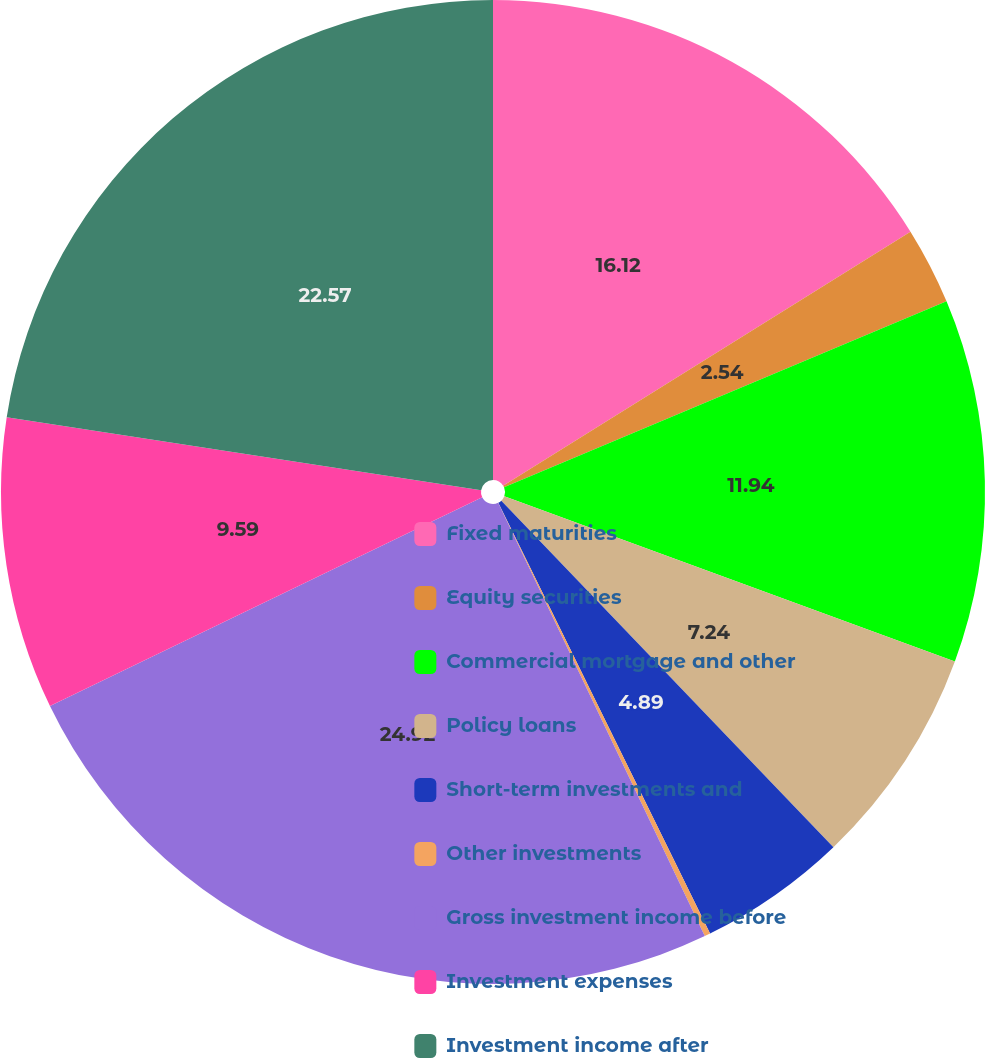<chart> <loc_0><loc_0><loc_500><loc_500><pie_chart><fcel>Fixed maturities<fcel>Equity securities<fcel>Commercial mortgage and other<fcel>Policy loans<fcel>Short-term investments and<fcel>Other investments<fcel>Gross investment income before<fcel>Investment expenses<fcel>Investment income after<nl><fcel>16.13%<fcel>2.54%<fcel>11.94%<fcel>7.24%<fcel>4.89%<fcel>0.19%<fcel>24.93%<fcel>9.59%<fcel>22.58%<nl></chart> 